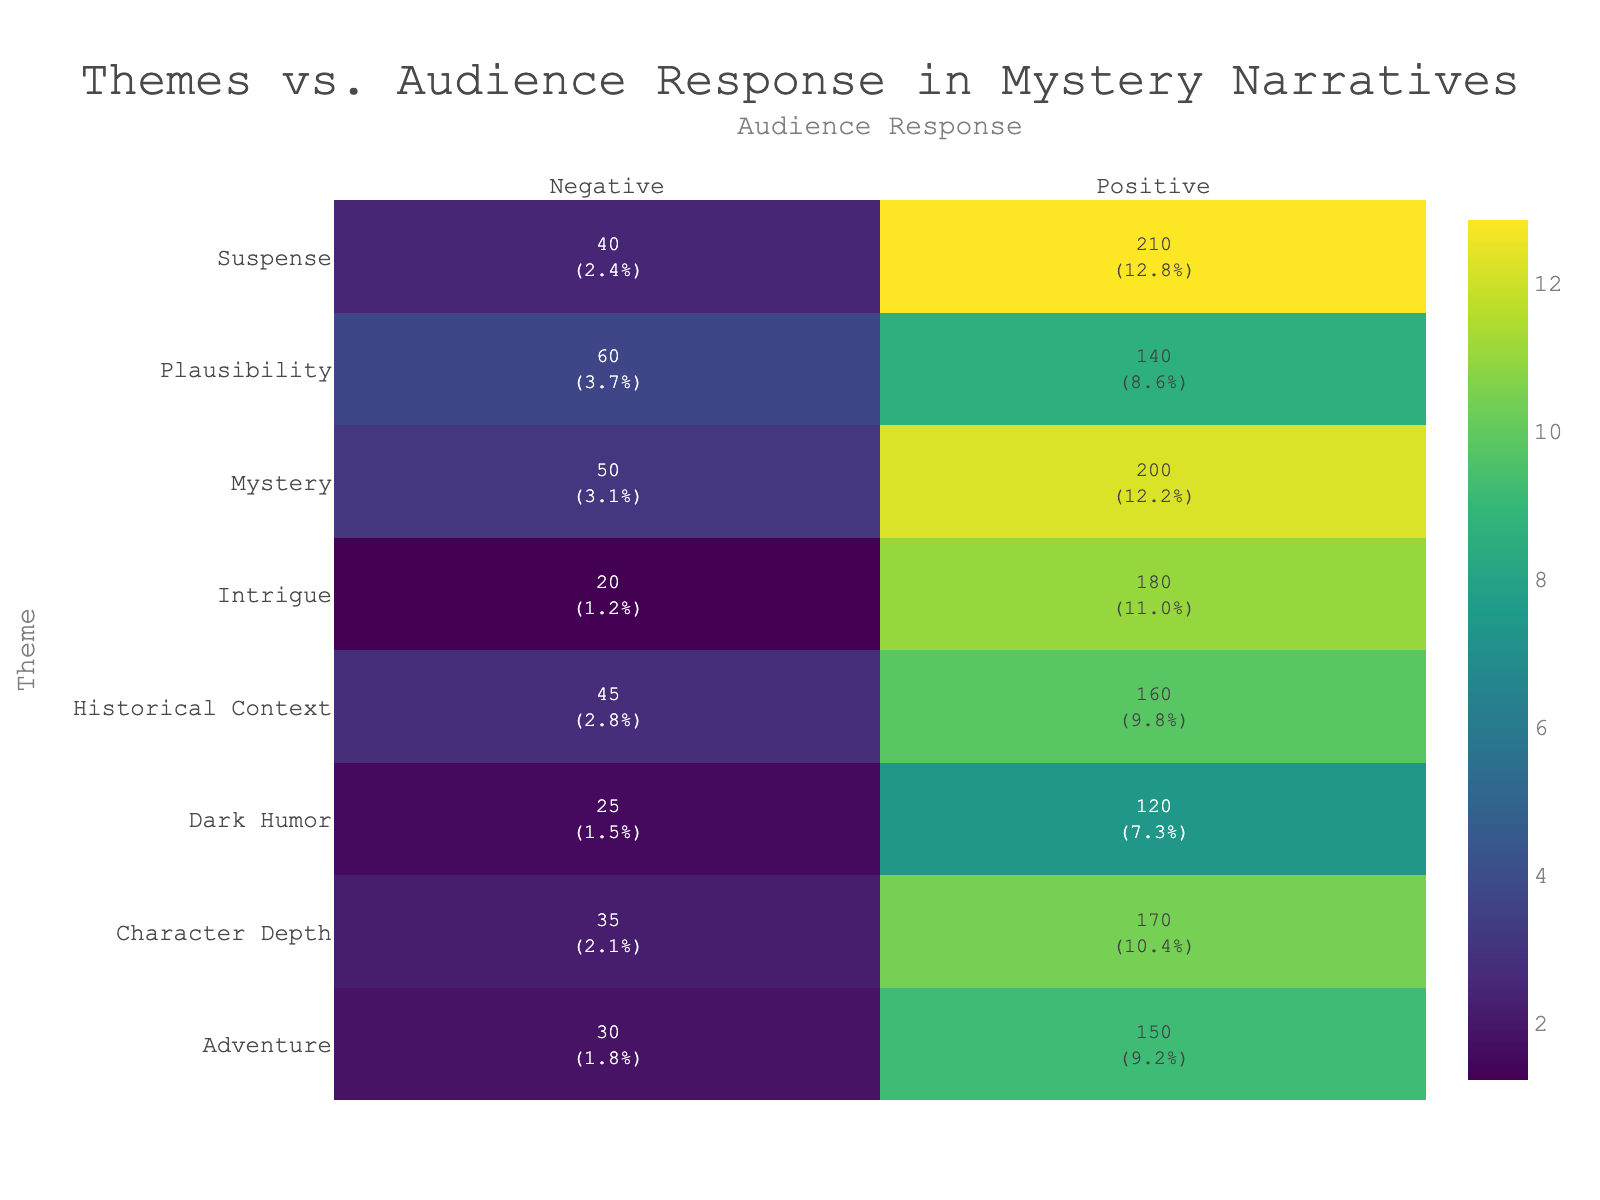What theme received the highest positive audience response? The theme with the highest positive audience response can be identified by looking for the maximum count in the "Positive" column. From the data, "Suspense" has 210 positive responses, which is the highest value among all themes.
Answer: Suspense What was the total number of positive responses across all themes? To find the total number of positive responses, we need to sum the counts from the "Positive" column: 150 (Adventure) + 200 (Mystery) + 180 (Intrigue) + 210 (Suspense) + 160 (Historical Context) + 170 (Character Depth) + 140 (Plausibility) + 120 (Dark Humor) = 1,430.
Answer: 1430 Is "Dark Humor" favored more positively than "Plausibility"? To determine this, we can compare the positive counts: "Dark Humor" has 120 positive responses while "Plausibility" has 140. Since 120 is less than 140, "Dark Humor" is not favored more positively than "Plausibility".
Answer: No What is the percentage of negative responses for the theme "Intrigue"? First, we find the total responses for "Intrigue" by adding positive and negative counts: 180 (Positive) + 20 (Negative) = 200. Then, the percentage of negative responses is calculated by (20 / 200) * 100 = 10%.
Answer: 10% Which theme has the least negative audience response? The theme with the least negative responses can be found by identifying the minimum value in the "Negative" column. The values are as follows: 30 (Adventure), 50 (Mystery), 20 (Intrigue), 40 (Suspense), 45 (Historical Context), 35 (Character Depth), 60 (Plausibility), 25 (Dark Humor). The least value is 20 for "Intrigue".
Answer: Intrigue What is the average count of negative responses across all themes? First, we sum the negative values: 30 (Adventure) + 50 (Mystery) + 20 (Intrigue) + 40 (Suspense) + 45 (Historical Context) + 35 (Character Depth) + 60 (Plausibility) + 25 (Dark Humor) = 305. Since there are 8 themes, the average is 305 / 8 = 38.125.
Answer: 38.125 Are there more positive responses or negative responses in total? To compare the totals, we first sum positive responses (1,430) and then negative responses (30 + 50 + 20 + 40 + 45 + 35 + 60 + 25 = 305). Since 1,430 is greater than 305, there are more positive responses overall.
Answer: Yes What percentage of the total responses does the theme "Suspense" represent? The total number of responses is calculated (1,430 for positive + 305 for negative = 1,735). The responses for "Suspense" is 210 (Positive) + 40 (Negative) = 250. The percentage is (250 / 1,735) * 100 = approximately 14.4%.
Answer: 14.4% 